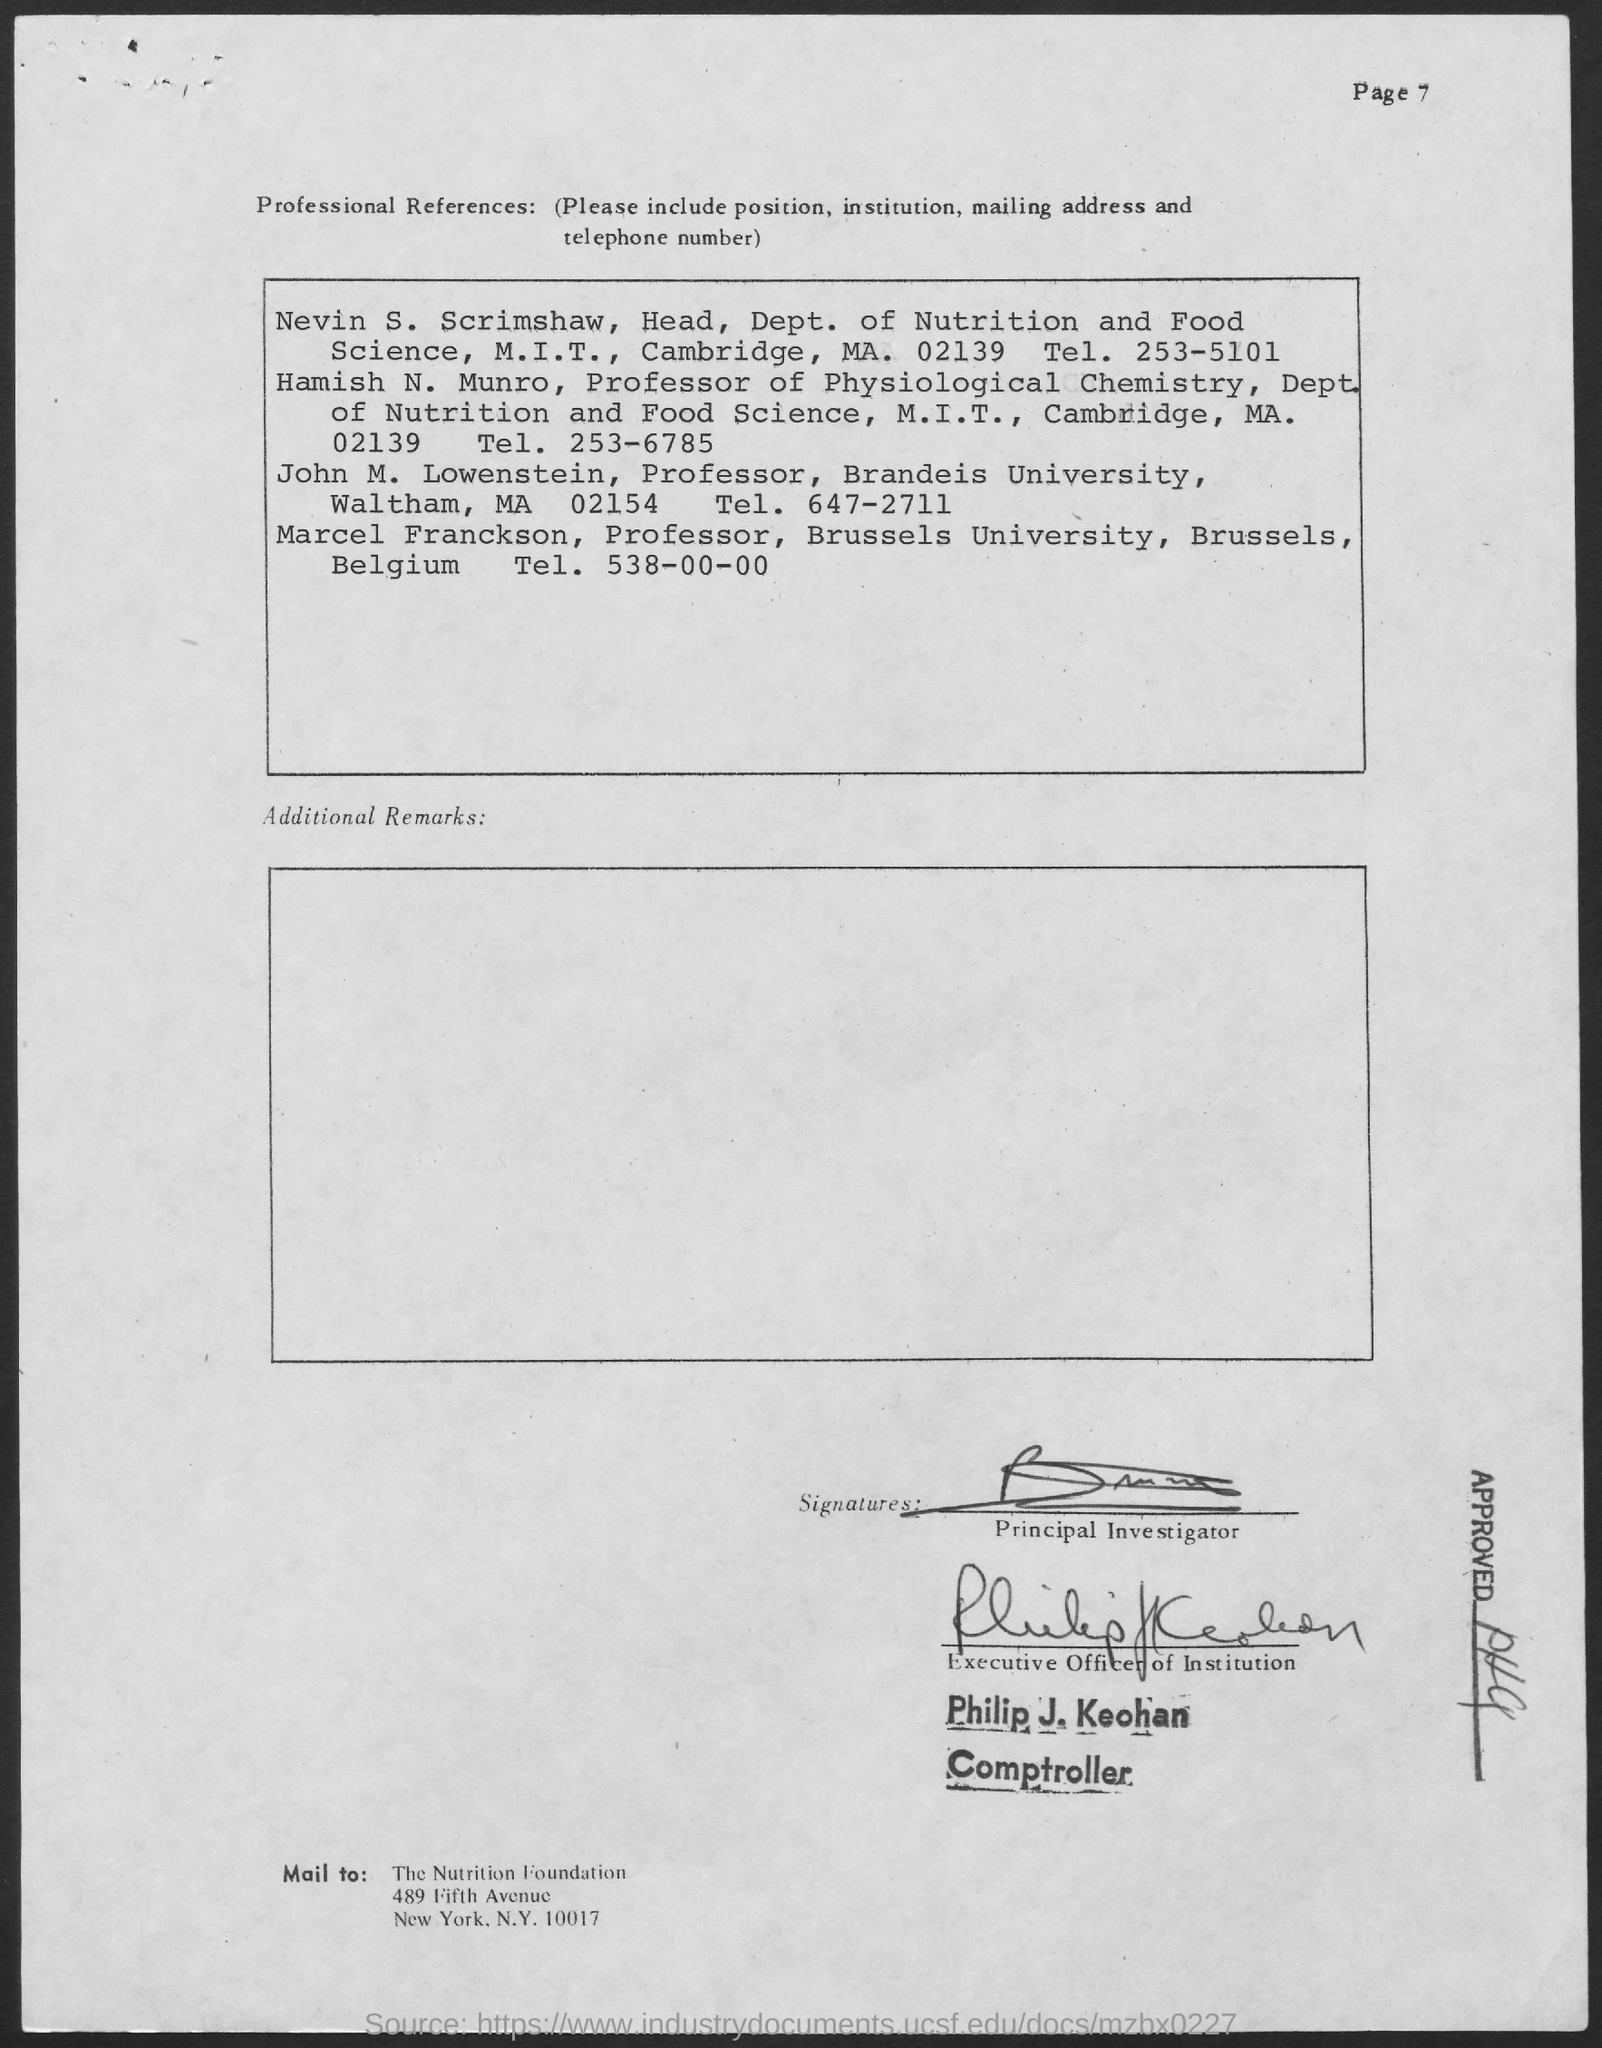Who is the head , dept . of nutrition and food science
Offer a very short reply. Nevin S . Scrimshaw. Who is the professor of physiological chemistry
Offer a very short reply. Hamish n. munro. Who is the professor of brandeis university
Offer a terse response. John m. lowenstein. Who is the professor the brussels university
Keep it short and to the point. Marcel franckson. What is the tel number of marcel franckson
Make the answer very short. 538-00-00. 